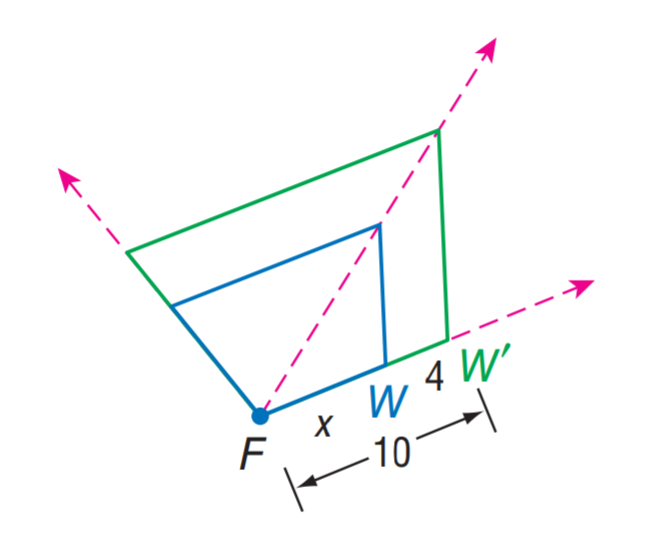Answer the mathemtical geometry problem and directly provide the correct option letter.
Question: Find x.
Choices: A: 4 B: 6 C: 8 D: 10 B 